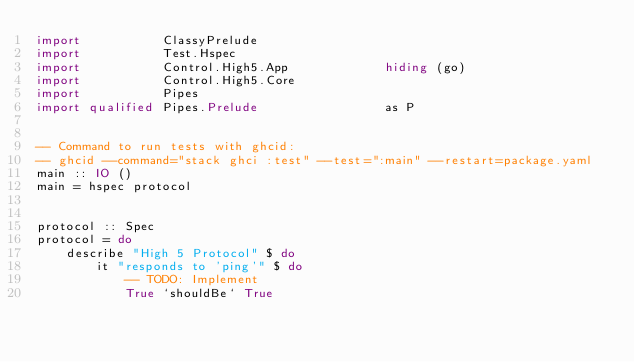<code> <loc_0><loc_0><loc_500><loc_500><_Haskell_>import           ClassyPrelude
import           Test.Hspec
import           Control.High5.App             hiding (go)
import           Control.High5.Core
import           Pipes
import qualified Pipes.Prelude                 as P


-- Command to run tests with ghcid:
-- ghcid --command="stack ghci :test" --test=":main" --restart=package.yaml
main :: IO ()
main = hspec protocol


protocol :: Spec
protocol = do
    describe "High 5 Protocol" $ do
        it "responds to 'ping'" $ do
            -- TODO: Implement
            True `shouldBe` True

</code> 